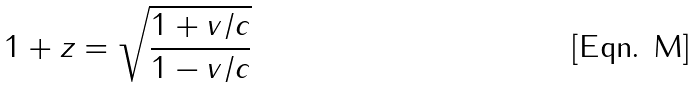Convert formula to latex. <formula><loc_0><loc_0><loc_500><loc_500>1 + z = \sqrt { \frac { 1 + v / c } { 1 - v / c } }</formula> 